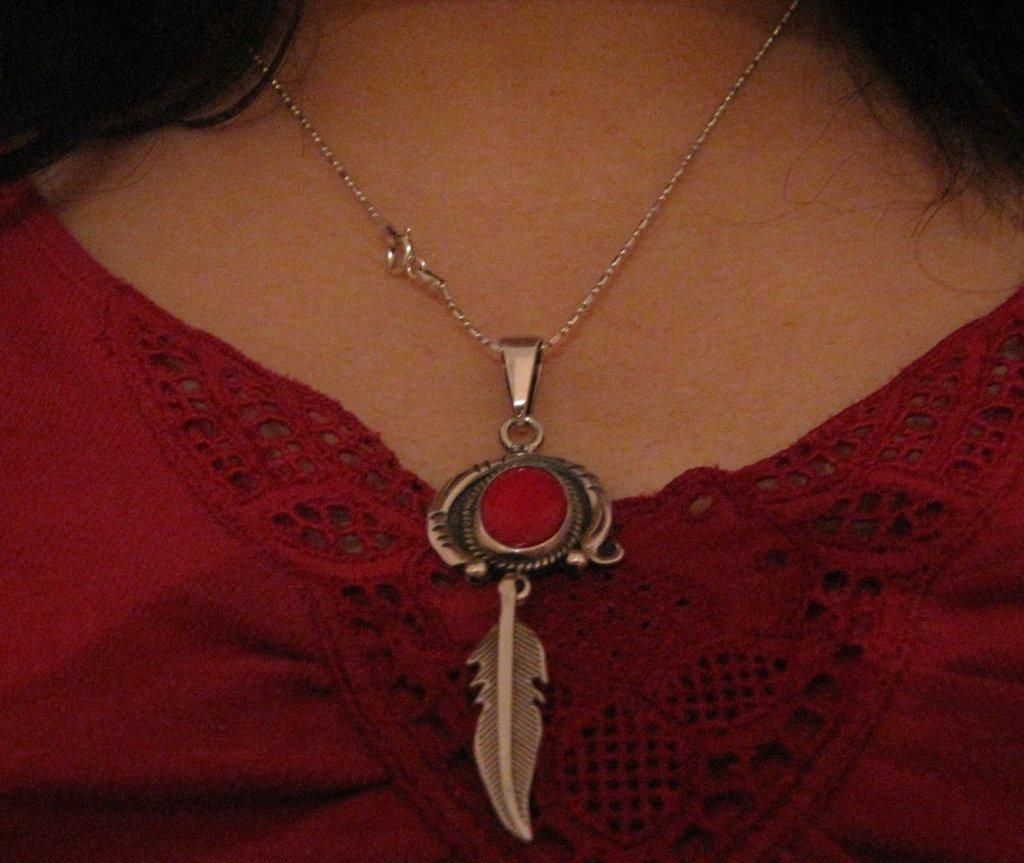How would you summarize this image in a sentence or two? In this picture we can see pendant with chain to a person's neck. 